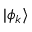Convert formula to latex. <formula><loc_0><loc_0><loc_500><loc_500>| \phi _ { k } \rangle</formula> 